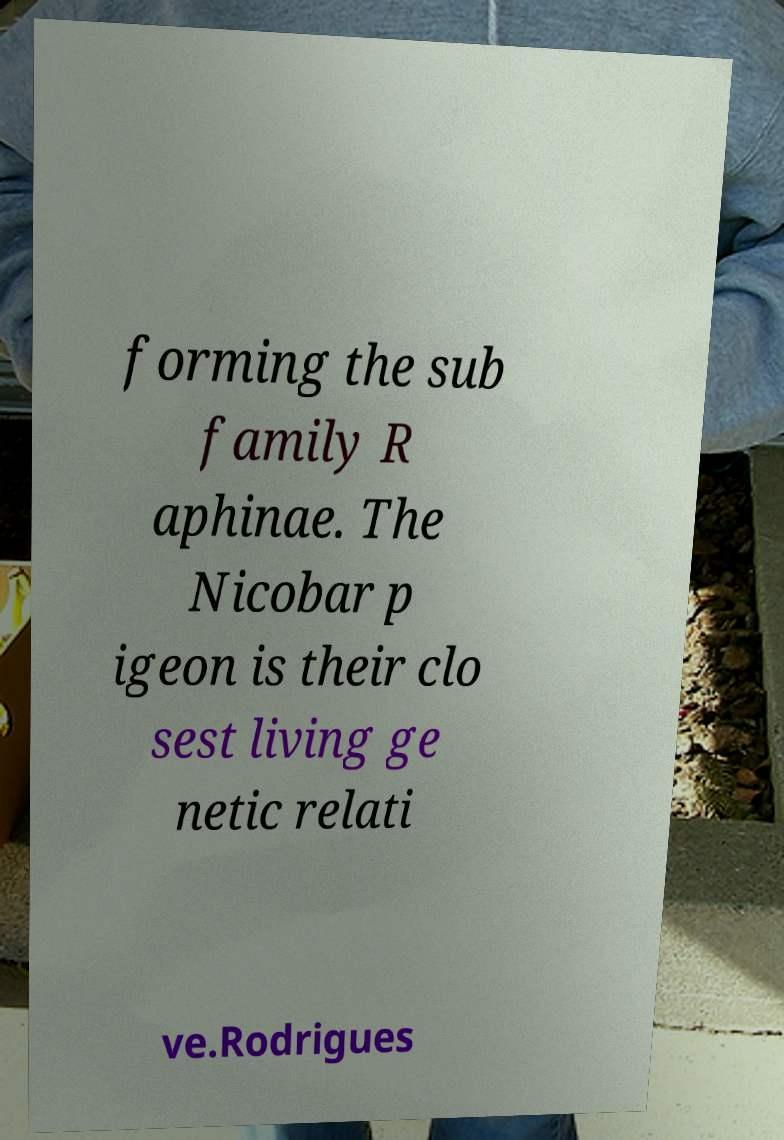What messages or text are displayed in this image? I need them in a readable, typed format. forming the sub family R aphinae. The Nicobar p igeon is their clo sest living ge netic relati ve.Rodrigues 